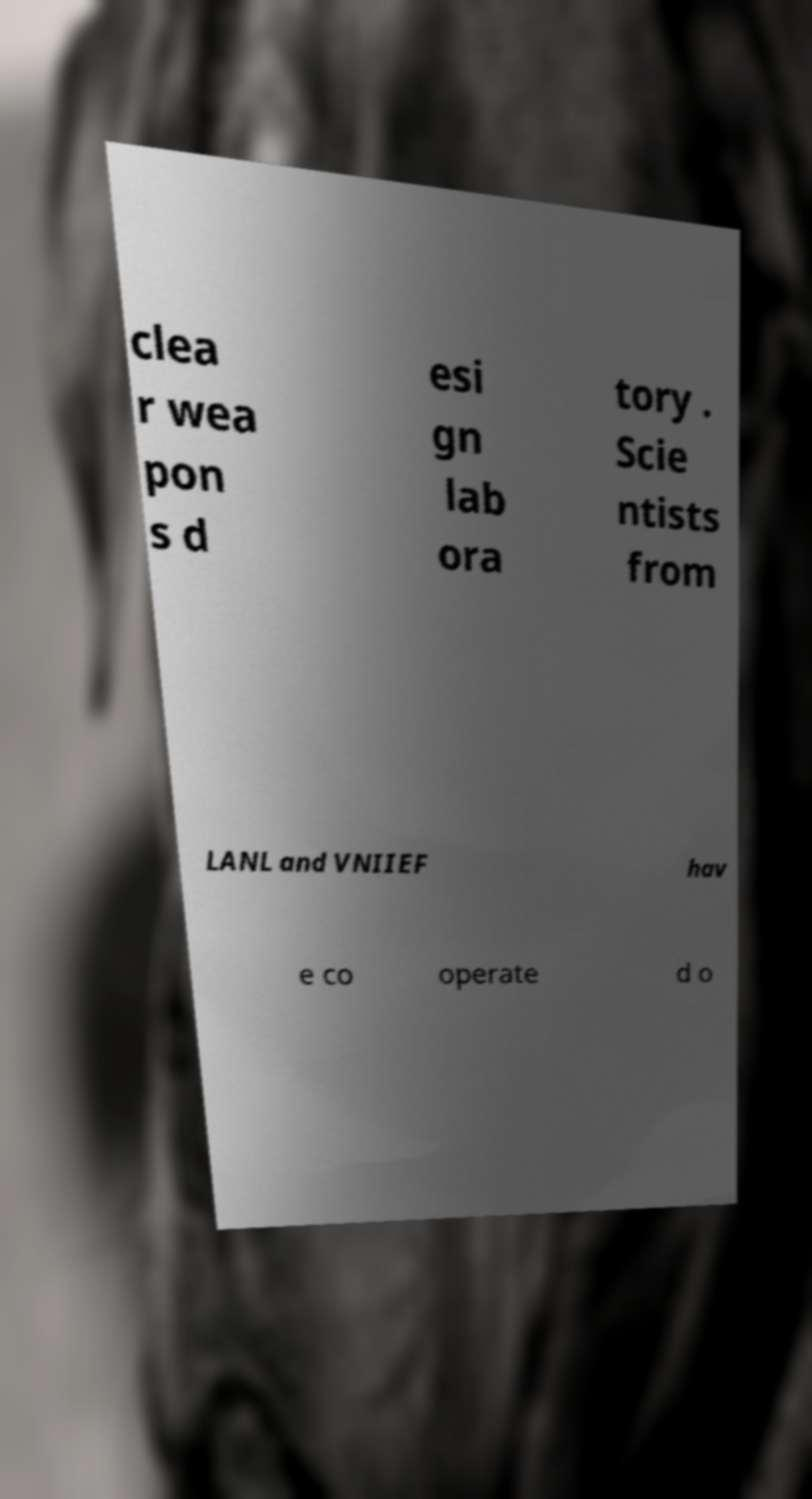Could you assist in decoding the text presented in this image and type it out clearly? clea r wea pon s d esi gn lab ora tory . Scie ntists from LANL and VNIIEF hav e co operate d o 